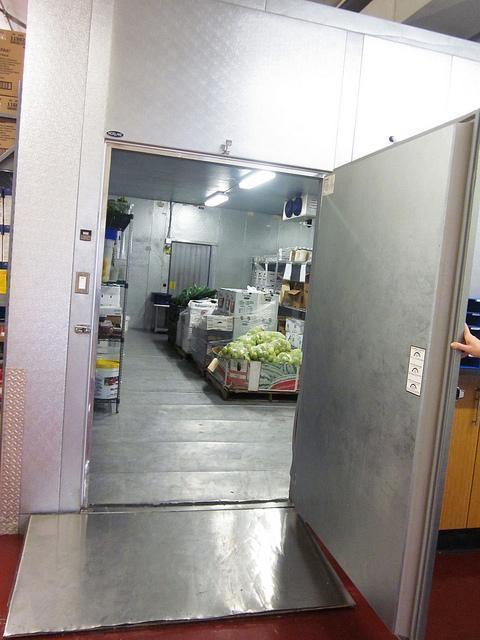What does this door lead to?
Choose the right answer and clarify with the format: 'Answer: answer
Rationale: rationale.'
Options: Dining area, walkin cooler, exit, bathroom. Answer: walkin cooler.
Rationale: The door goes to a giant refrigerator. 